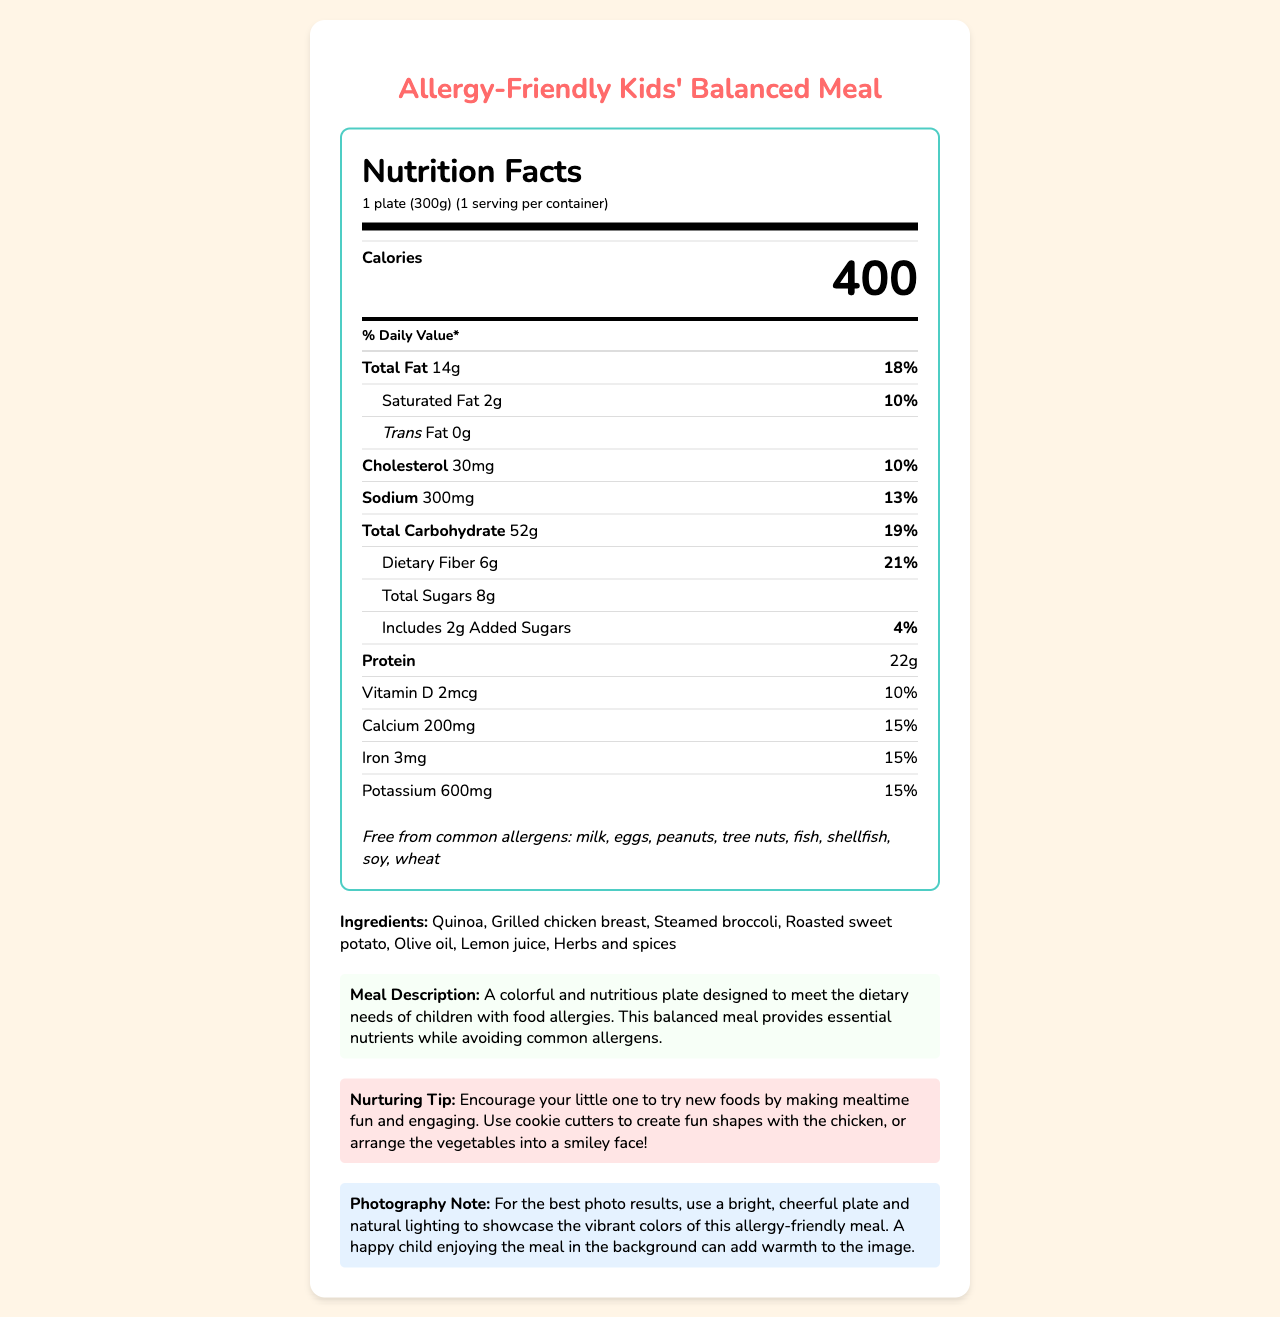what is the serving size? The serving size is stated in the "serving info" section of the document.
Answer: 1 plate (300g) how many calories are there per serving? The number of calories per serving is listed prominently in the document.
Answer: 400 what percentage of the daily value is the total fat? The percentage of the daily value for total fat is provided next to the amount of total fat.
Answer: 18% name three ingredients in the meal. These ingredients are listed in the ingredients section of the label.
Answer: Quinoa, Grilled chicken breast, Steamed broccoli is this meal free from common allergens like milk and eggs? The allergen information in the document confirms that the meal is free from milk, eggs, and other common allergens.
Answer: Yes how much dietary fiber does this meal provide? The amount of dietary fiber is listed under the total carbohydrate section.
Answer: 6g what is the main source of protein in the meal? The ingredient list specifies grilled chicken breast, which is a primary protein source.
Answer: Grilled chicken breast which vitamin is listed with a 10% daily value? A. Vitamin A B. Vitamin C C. Vitamin D D. Vitamin B12 The table indicates Vitamin D has a daily value of 10%.
Answer: C how much sodium does the meal contain? A. 100mg B. 200mg C. 300mg D. 400mg The sodium content listed is 300mg.
Answer: C are there any added sugars in the meal? The document indicates that the meal includes 2g of added sugars.
Answer: Yes does the meal contain any Trans Fat? The document specifies that the meal contains 0g of Trans Fat.
Answer: No how many servings are in one container? The serving information shows that there is 1 serving per container.
Answer: 1 briefly describe the meal. This summary captures the description provided under the meal description section.
Answer: A colorful and nutritious plate designed to meet the dietary needs of children with food allergies. This balanced meal provides essential nutrients while avoiding common allergens. can you determine the exact amount of olive oil used in the meal? The ingredient list includes olive oil, but the exact amount is not provided in the document.
Answer: Not enough information 